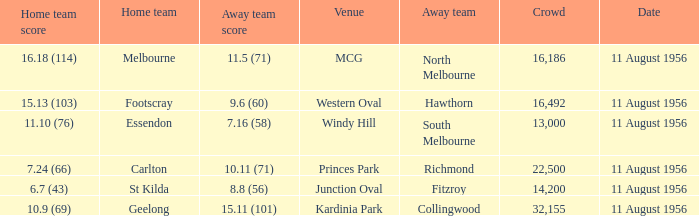What home team played at western oval? Footscray. 